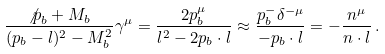<formula> <loc_0><loc_0><loc_500><loc_500>\frac { { \not p } _ { b } + M _ { b } } { ( p _ { b } - l ) ^ { 2 } - M _ { b } ^ { 2 } } \gamma ^ { \mu } = \frac { 2 p _ { b } ^ { \mu } } { l ^ { 2 } - 2 p _ { b } \cdot l } \approx \frac { p _ { b } ^ { - } \delta ^ { - \mu } } { - p _ { b } \cdot l } = - \frac { n ^ { \mu } } { n \cdot l } \, .</formula> 